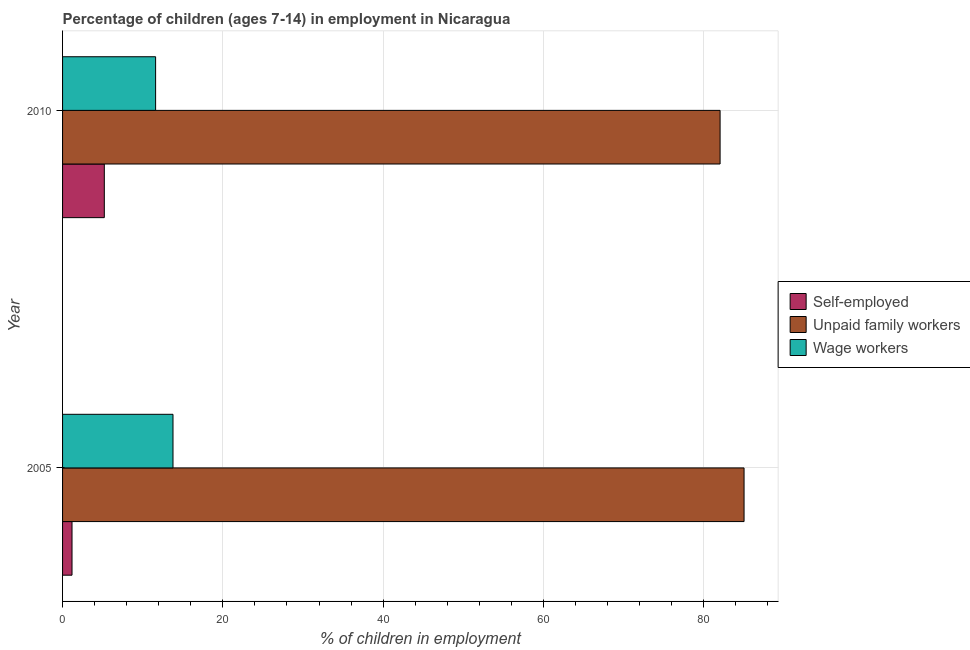Are the number of bars per tick equal to the number of legend labels?
Keep it short and to the point. Yes. How many bars are there on the 1st tick from the top?
Provide a succinct answer. 3. What is the label of the 2nd group of bars from the top?
Offer a very short reply. 2005. In how many cases, is the number of bars for a given year not equal to the number of legend labels?
Make the answer very short. 0. What is the percentage of children employed as unpaid family workers in 2005?
Offer a terse response. 85.04. Across all years, what is the maximum percentage of self employed children?
Provide a short and direct response. 5.21. Across all years, what is the minimum percentage of children employed as wage workers?
Provide a succinct answer. 11.61. In which year was the percentage of self employed children maximum?
Give a very brief answer. 2010. What is the total percentage of self employed children in the graph?
Your answer should be compact. 6.39. What is the difference between the percentage of children employed as wage workers in 2005 and that in 2010?
Offer a very short reply. 2.17. What is the difference between the percentage of children employed as wage workers in 2010 and the percentage of self employed children in 2005?
Make the answer very short. 10.43. What is the average percentage of children employed as wage workers per year?
Your answer should be compact. 12.7. In the year 2010, what is the difference between the percentage of children employed as unpaid family workers and percentage of self employed children?
Your response must be concise. 76.84. What is the ratio of the percentage of children employed as unpaid family workers in 2005 to that in 2010?
Your answer should be very brief. 1.04. Is the difference between the percentage of children employed as unpaid family workers in 2005 and 2010 greater than the difference between the percentage of self employed children in 2005 and 2010?
Your response must be concise. Yes. In how many years, is the percentage of children employed as unpaid family workers greater than the average percentage of children employed as unpaid family workers taken over all years?
Ensure brevity in your answer.  1. What does the 2nd bar from the top in 2010 represents?
Keep it short and to the point. Unpaid family workers. What does the 1st bar from the bottom in 2005 represents?
Keep it short and to the point. Self-employed. How many bars are there?
Provide a short and direct response. 6. Where does the legend appear in the graph?
Your answer should be compact. Center right. How are the legend labels stacked?
Make the answer very short. Vertical. What is the title of the graph?
Offer a very short reply. Percentage of children (ages 7-14) in employment in Nicaragua. What is the label or title of the X-axis?
Your answer should be very brief. % of children in employment. What is the label or title of the Y-axis?
Offer a terse response. Year. What is the % of children in employment of Self-employed in 2005?
Keep it short and to the point. 1.18. What is the % of children in employment of Unpaid family workers in 2005?
Make the answer very short. 85.04. What is the % of children in employment of Wage workers in 2005?
Your answer should be very brief. 13.78. What is the % of children in employment of Self-employed in 2010?
Offer a terse response. 5.21. What is the % of children in employment in Unpaid family workers in 2010?
Provide a succinct answer. 82.05. What is the % of children in employment in Wage workers in 2010?
Your response must be concise. 11.61. Across all years, what is the maximum % of children in employment in Self-employed?
Your answer should be compact. 5.21. Across all years, what is the maximum % of children in employment in Unpaid family workers?
Provide a short and direct response. 85.04. Across all years, what is the maximum % of children in employment of Wage workers?
Give a very brief answer. 13.78. Across all years, what is the minimum % of children in employment of Self-employed?
Give a very brief answer. 1.18. Across all years, what is the minimum % of children in employment in Unpaid family workers?
Your answer should be compact. 82.05. Across all years, what is the minimum % of children in employment of Wage workers?
Your response must be concise. 11.61. What is the total % of children in employment in Self-employed in the graph?
Make the answer very short. 6.39. What is the total % of children in employment in Unpaid family workers in the graph?
Ensure brevity in your answer.  167.09. What is the total % of children in employment of Wage workers in the graph?
Give a very brief answer. 25.39. What is the difference between the % of children in employment in Self-employed in 2005 and that in 2010?
Provide a short and direct response. -4.03. What is the difference between the % of children in employment in Unpaid family workers in 2005 and that in 2010?
Your answer should be compact. 2.99. What is the difference between the % of children in employment of Wage workers in 2005 and that in 2010?
Ensure brevity in your answer.  2.17. What is the difference between the % of children in employment of Self-employed in 2005 and the % of children in employment of Unpaid family workers in 2010?
Offer a very short reply. -80.87. What is the difference between the % of children in employment of Self-employed in 2005 and the % of children in employment of Wage workers in 2010?
Keep it short and to the point. -10.43. What is the difference between the % of children in employment in Unpaid family workers in 2005 and the % of children in employment in Wage workers in 2010?
Offer a terse response. 73.43. What is the average % of children in employment of Self-employed per year?
Keep it short and to the point. 3.19. What is the average % of children in employment in Unpaid family workers per year?
Provide a short and direct response. 83.55. What is the average % of children in employment of Wage workers per year?
Your response must be concise. 12.7. In the year 2005, what is the difference between the % of children in employment of Self-employed and % of children in employment of Unpaid family workers?
Your answer should be very brief. -83.86. In the year 2005, what is the difference between the % of children in employment of Unpaid family workers and % of children in employment of Wage workers?
Give a very brief answer. 71.26. In the year 2010, what is the difference between the % of children in employment of Self-employed and % of children in employment of Unpaid family workers?
Offer a very short reply. -76.84. In the year 2010, what is the difference between the % of children in employment in Unpaid family workers and % of children in employment in Wage workers?
Offer a very short reply. 70.44. What is the ratio of the % of children in employment in Self-employed in 2005 to that in 2010?
Ensure brevity in your answer.  0.23. What is the ratio of the % of children in employment in Unpaid family workers in 2005 to that in 2010?
Offer a terse response. 1.04. What is the ratio of the % of children in employment in Wage workers in 2005 to that in 2010?
Keep it short and to the point. 1.19. What is the difference between the highest and the second highest % of children in employment of Self-employed?
Give a very brief answer. 4.03. What is the difference between the highest and the second highest % of children in employment in Unpaid family workers?
Give a very brief answer. 2.99. What is the difference between the highest and the second highest % of children in employment of Wage workers?
Your answer should be very brief. 2.17. What is the difference between the highest and the lowest % of children in employment in Self-employed?
Keep it short and to the point. 4.03. What is the difference between the highest and the lowest % of children in employment of Unpaid family workers?
Your answer should be very brief. 2.99. What is the difference between the highest and the lowest % of children in employment in Wage workers?
Give a very brief answer. 2.17. 